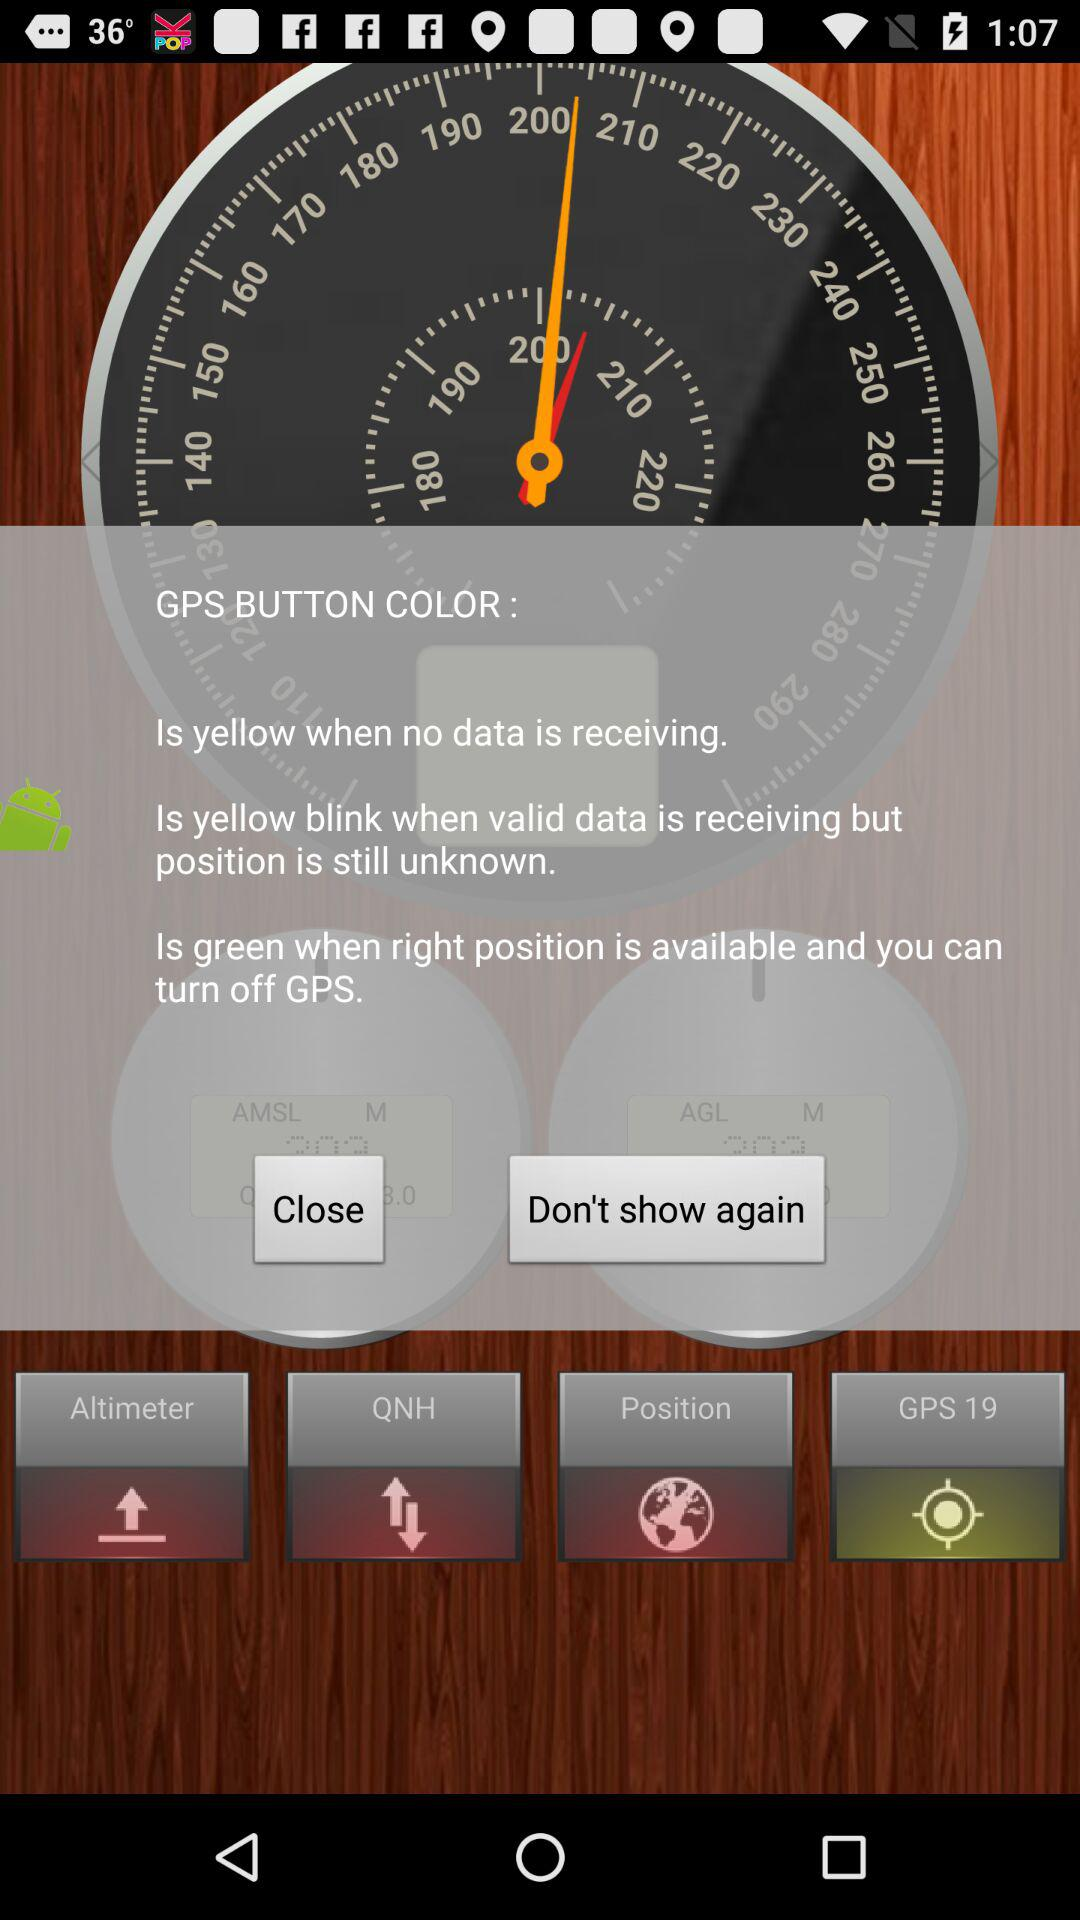What is meaning of green color? The meaning of green color is when the right position is available and you can turn off GPS. 